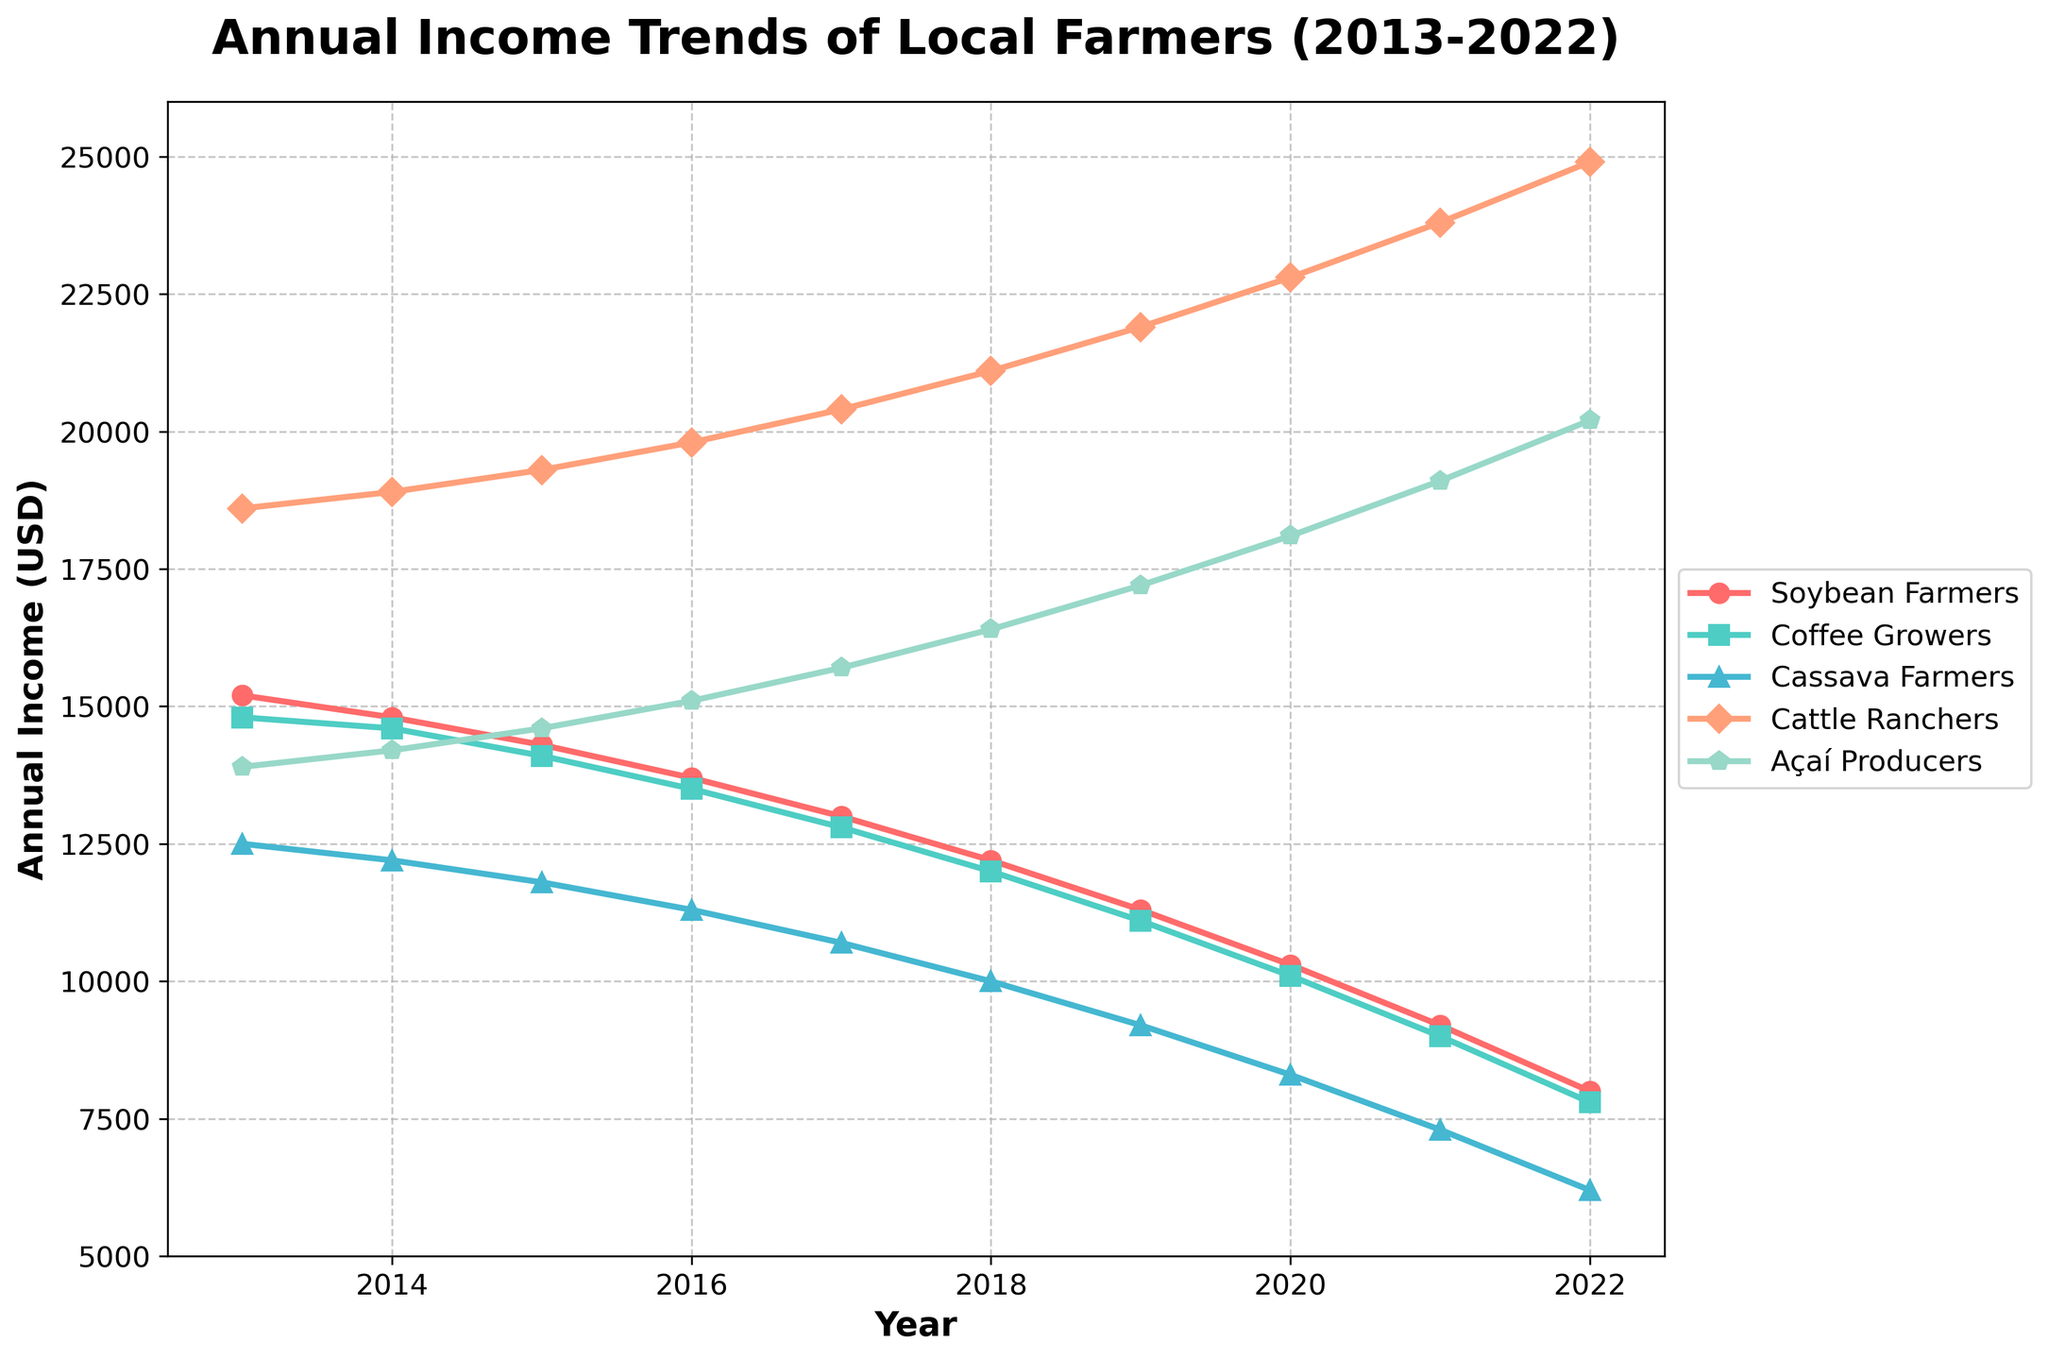What trend do we observe for the annual income of Coffee Growers from 2013 to 2022? Looking at the line representing Coffee Growers in the chart, we see a consistent downward trend in their annual income over the years, starting at around $14,800 in 2013 and dropping to about $7,800 by 2022.
Answer: Downward trend Which group experienced the highest increase in annual income over the decade? Observing the lines, Cattle Ranchers show an increasing trend in annual income, starting from $18,600 in 2013 and rising to $24,900 in 2022. This is an overall increase of $6,300, the highest among all groups.
Answer: Cattle Ranchers In what year did Soybean Farmers' annual income fall below $15,000? Looking at the line for Soybean Farmers, their annual income dropped below $15,000 in the year 2014 when it reached $14,800.
Answer: 2014 How do the income trends of Cassava Farmers and Açaí Producers compare from 2013 to 2022 in terms of direction? Cassava Farmers' income shows a consistent downward trend, whereas Açaí Producers' income shows an upward trend when viewed year by year over the decade.
Answer: Cassava Farmers: downward, Açaí Producers: upward What was the difference in annual income between Açaí Producers and Cassava Farmers in 2022? In 2022, Açaí Producers had an annual income of $20,200, while Cassava Farmers had $6,200. The difference between them is $20,200 - $6,200 = $14,000.
Answer: $14,000 Which group had the lowest annual income in 2021 and what was it? In 2021, Cassava Farmers had the lowest annual income of $7,300, as represented by the lowest point in the lines for that year.
Answer: Cassava Farmers, $7,300 Between which consecutive years did Coffee Growers experience the steepest decline in income? Observing the year-to-year changes in the Coffee Growers' line, the steepest decline occurs between 2020 and 2021, dropping from $10,100 to $9,000, a difference of $1,100.
Answer: 2020 to 2021 What is the average annual income of Cattle Ranchers over the decade? Summing up the annual incomes of Cattle Ranchers from 2013 to 2022: (18600 + 18900 + 19300 + 19800 + 20400 + 21100 + 21900 + 22800 + 23800 + 24900) = 21,7000. The average is 217000 / 10 = 21700.
Answer: $21,700 Which group saw their annual income decrease to less than half of their initial income in 2013 by 2022? For Soybean Farmers, their income in 2013 was $15,200, and by 2022, it fell to $8,000, which is less than half of $15,200 (which would be $7,600).
Answer: Soybean Farmers 